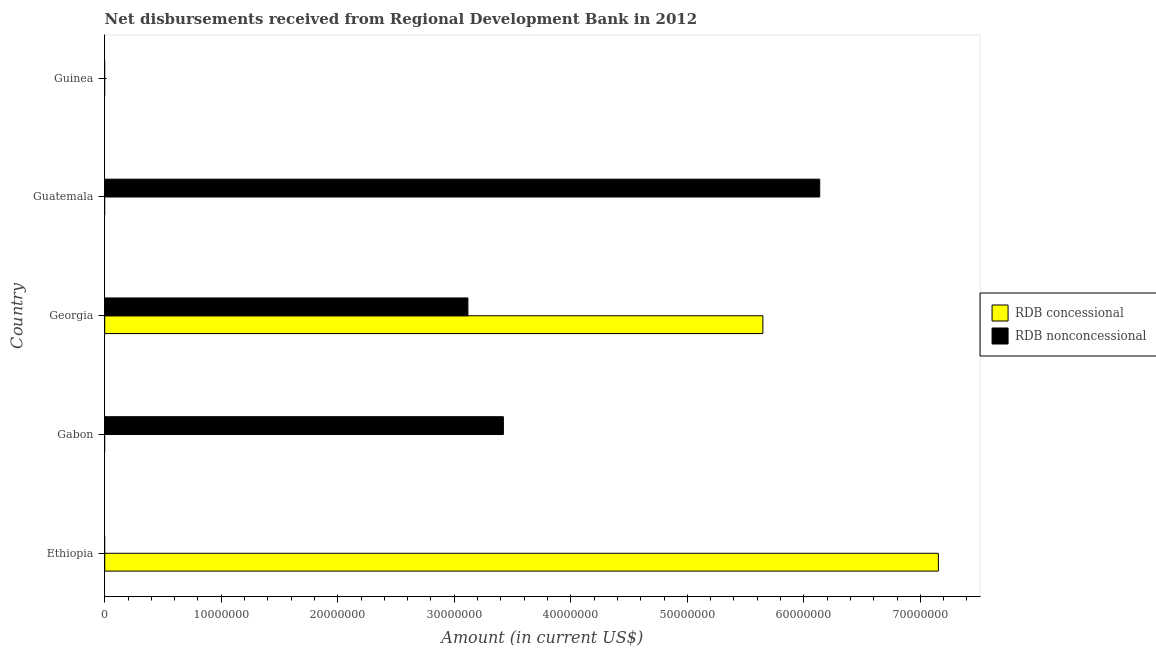Are the number of bars per tick equal to the number of legend labels?
Your response must be concise. No. How many bars are there on the 2nd tick from the bottom?
Offer a very short reply. 1. What is the label of the 2nd group of bars from the top?
Offer a terse response. Guatemala. In how many cases, is the number of bars for a given country not equal to the number of legend labels?
Provide a short and direct response. 4. What is the net concessional disbursements from rdb in Gabon?
Provide a succinct answer. 0. Across all countries, what is the maximum net non concessional disbursements from rdb?
Offer a terse response. 6.14e+07. Across all countries, what is the minimum net concessional disbursements from rdb?
Your answer should be very brief. 0. In which country was the net non concessional disbursements from rdb maximum?
Offer a very short reply. Guatemala. What is the total net non concessional disbursements from rdb in the graph?
Your answer should be compact. 1.27e+08. What is the difference between the net concessional disbursements from rdb in Georgia and the net non concessional disbursements from rdb in Gabon?
Ensure brevity in your answer.  2.23e+07. What is the average net non concessional disbursements from rdb per country?
Make the answer very short. 2.53e+07. What is the difference between the net concessional disbursements from rdb and net non concessional disbursements from rdb in Georgia?
Your response must be concise. 2.53e+07. In how many countries, is the net concessional disbursements from rdb greater than 42000000 US$?
Offer a terse response. 2. What is the ratio of the net non concessional disbursements from rdb in Gabon to that in Guatemala?
Offer a very short reply. 0.56. What is the difference between the highest and the second highest net non concessional disbursements from rdb?
Provide a short and direct response. 2.71e+07. What is the difference between the highest and the lowest net concessional disbursements from rdb?
Provide a succinct answer. 7.15e+07. How many bars are there?
Provide a succinct answer. 5. Are all the bars in the graph horizontal?
Your answer should be very brief. Yes. How many countries are there in the graph?
Make the answer very short. 5. Does the graph contain grids?
Ensure brevity in your answer.  No. How are the legend labels stacked?
Offer a very short reply. Vertical. What is the title of the graph?
Make the answer very short. Net disbursements received from Regional Development Bank in 2012. Does "All education staff compensation" appear as one of the legend labels in the graph?
Ensure brevity in your answer.  No. What is the label or title of the X-axis?
Keep it short and to the point. Amount (in current US$). What is the Amount (in current US$) of RDB concessional in Ethiopia?
Your response must be concise. 7.15e+07. What is the Amount (in current US$) in RDB concessional in Gabon?
Offer a very short reply. 0. What is the Amount (in current US$) in RDB nonconcessional in Gabon?
Offer a terse response. 3.42e+07. What is the Amount (in current US$) in RDB concessional in Georgia?
Provide a short and direct response. 5.65e+07. What is the Amount (in current US$) of RDB nonconcessional in Georgia?
Keep it short and to the point. 3.12e+07. What is the Amount (in current US$) of RDB nonconcessional in Guatemala?
Provide a succinct answer. 6.14e+07. What is the Amount (in current US$) in RDB nonconcessional in Guinea?
Your response must be concise. 0. Across all countries, what is the maximum Amount (in current US$) of RDB concessional?
Give a very brief answer. 7.15e+07. Across all countries, what is the maximum Amount (in current US$) in RDB nonconcessional?
Offer a terse response. 6.14e+07. What is the total Amount (in current US$) in RDB concessional in the graph?
Give a very brief answer. 1.28e+08. What is the total Amount (in current US$) in RDB nonconcessional in the graph?
Give a very brief answer. 1.27e+08. What is the difference between the Amount (in current US$) in RDB concessional in Ethiopia and that in Georgia?
Give a very brief answer. 1.51e+07. What is the difference between the Amount (in current US$) in RDB nonconcessional in Gabon and that in Georgia?
Ensure brevity in your answer.  3.04e+06. What is the difference between the Amount (in current US$) in RDB nonconcessional in Gabon and that in Guatemala?
Provide a short and direct response. -2.71e+07. What is the difference between the Amount (in current US$) in RDB nonconcessional in Georgia and that in Guatemala?
Your response must be concise. -3.02e+07. What is the difference between the Amount (in current US$) in RDB concessional in Ethiopia and the Amount (in current US$) in RDB nonconcessional in Gabon?
Give a very brief answer. 3.73e+07. What is the difference between the Amount (in current US$) of RDB concessional in Ethiopia and the Amount (in current US$) of RDB nonconcessional in Georgia?
Offer a very short reply. 4.04e+07. What is the difference between the Amount (in current US$) of RDB concessional in Ethiopia and the Amount (in current US$) of RDB nonconcessional in Guatemala?
Keep it short and to the point. 1.02e+07. What is the difference between the Amount (in current US$) of RDB concessional in Georgia and the Amount (in current US$) of RDB nonconcessional in Guatemala?
Ensure brevity in your answer.  -4.88e+06. What is the average Amount (in current US$) of RDB concessional per country?
Provide a short and direct response. 2.56e+07. What is the average Amount (in current US$) in RDB nonconcessional per country?
Offer a terse response. 2.53e+07. What is the difference between the Amount (in current US$) of RDB concessional and Amount (in current US$) of RDB nonconcessional in Georgia?
Offer a terse response. 2.53e+07. What is the ratio of the Amount (in current US$) in RDB concessional in Ethiopia to that in Georgia?
Your answer should be very brief. 1.27. What is the ratio of the Amount (in current US$) in RDB nonconcessional in Gabon to that in Georgia?
Offer a terse response. 1.1. What is the ratio of the Amount (in current US$) of RDB nonconcessional in Gabon to that in Guatemala?
Your response must be concise. 0.56. What is the ratio of the Amount (in current US$) in RDB nonconcessional in Georgia to that in Guatemala?
Offer a terse response. 0.51. What is the difference between the highest and the second highest Amount (in current US$) of RDB nonconcessional?
Your answer should be very brief. 2.71e+07. What is the difference between the highest and the lowest Amount (in current US$) of RDB concessional?
Provide a succinct answer. 7.15e+07. What is the difference between the highest and the lowest Amount (in current US$) in RDB nonconcessional?
Your response must be concise. 6.14e+07. 